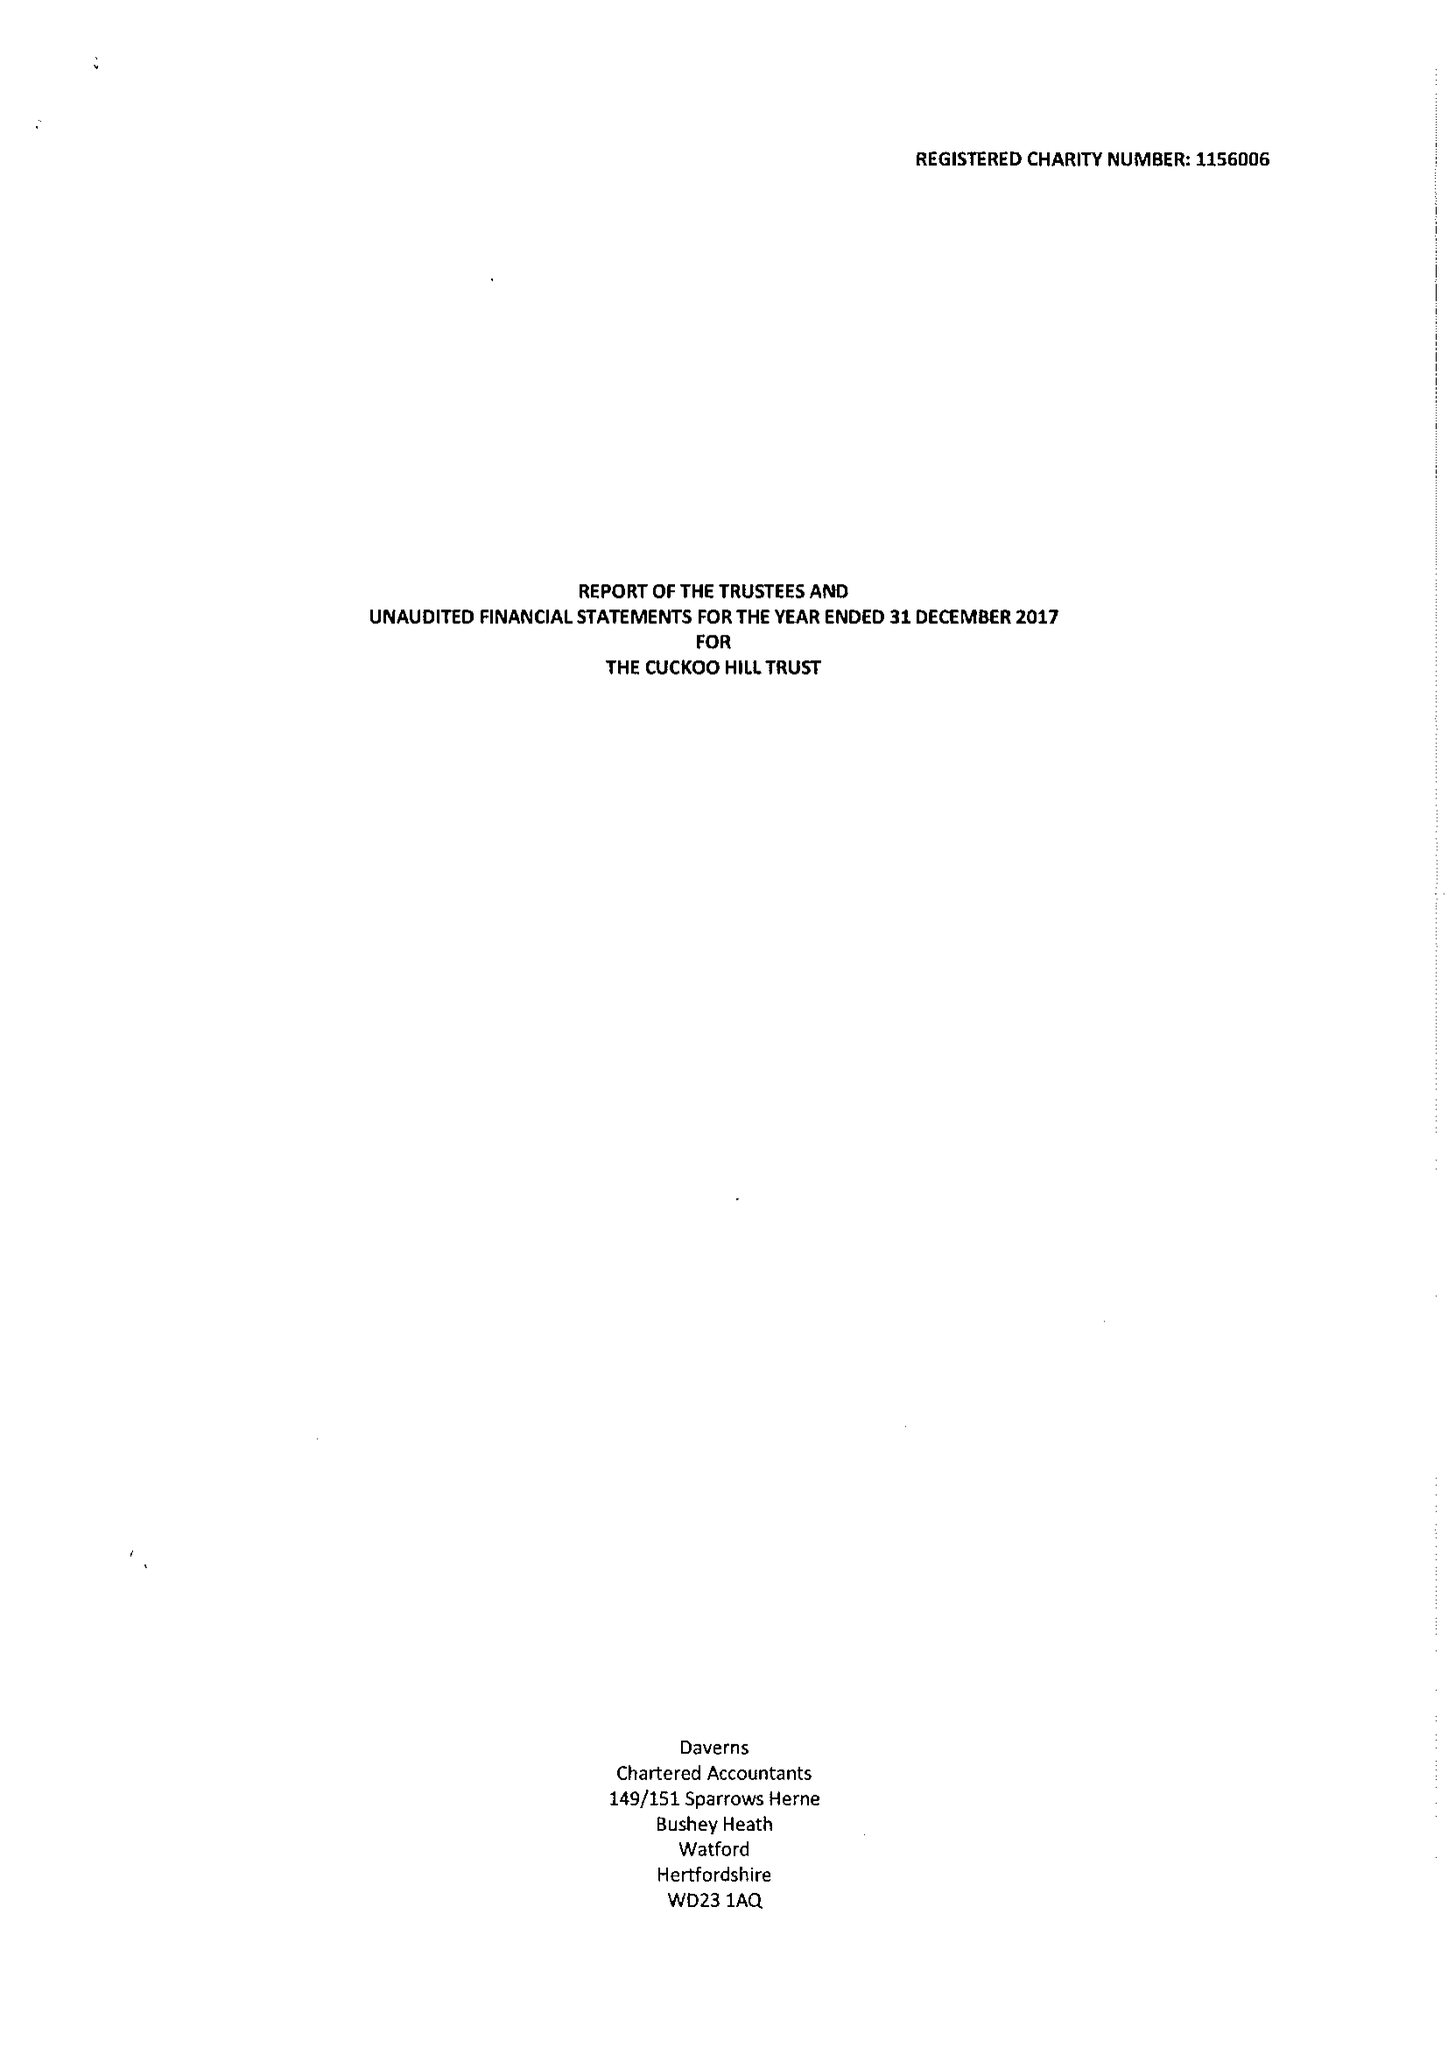What is the value for the report_date?
Answer the question using a single word or phrase. 2017-12-31 